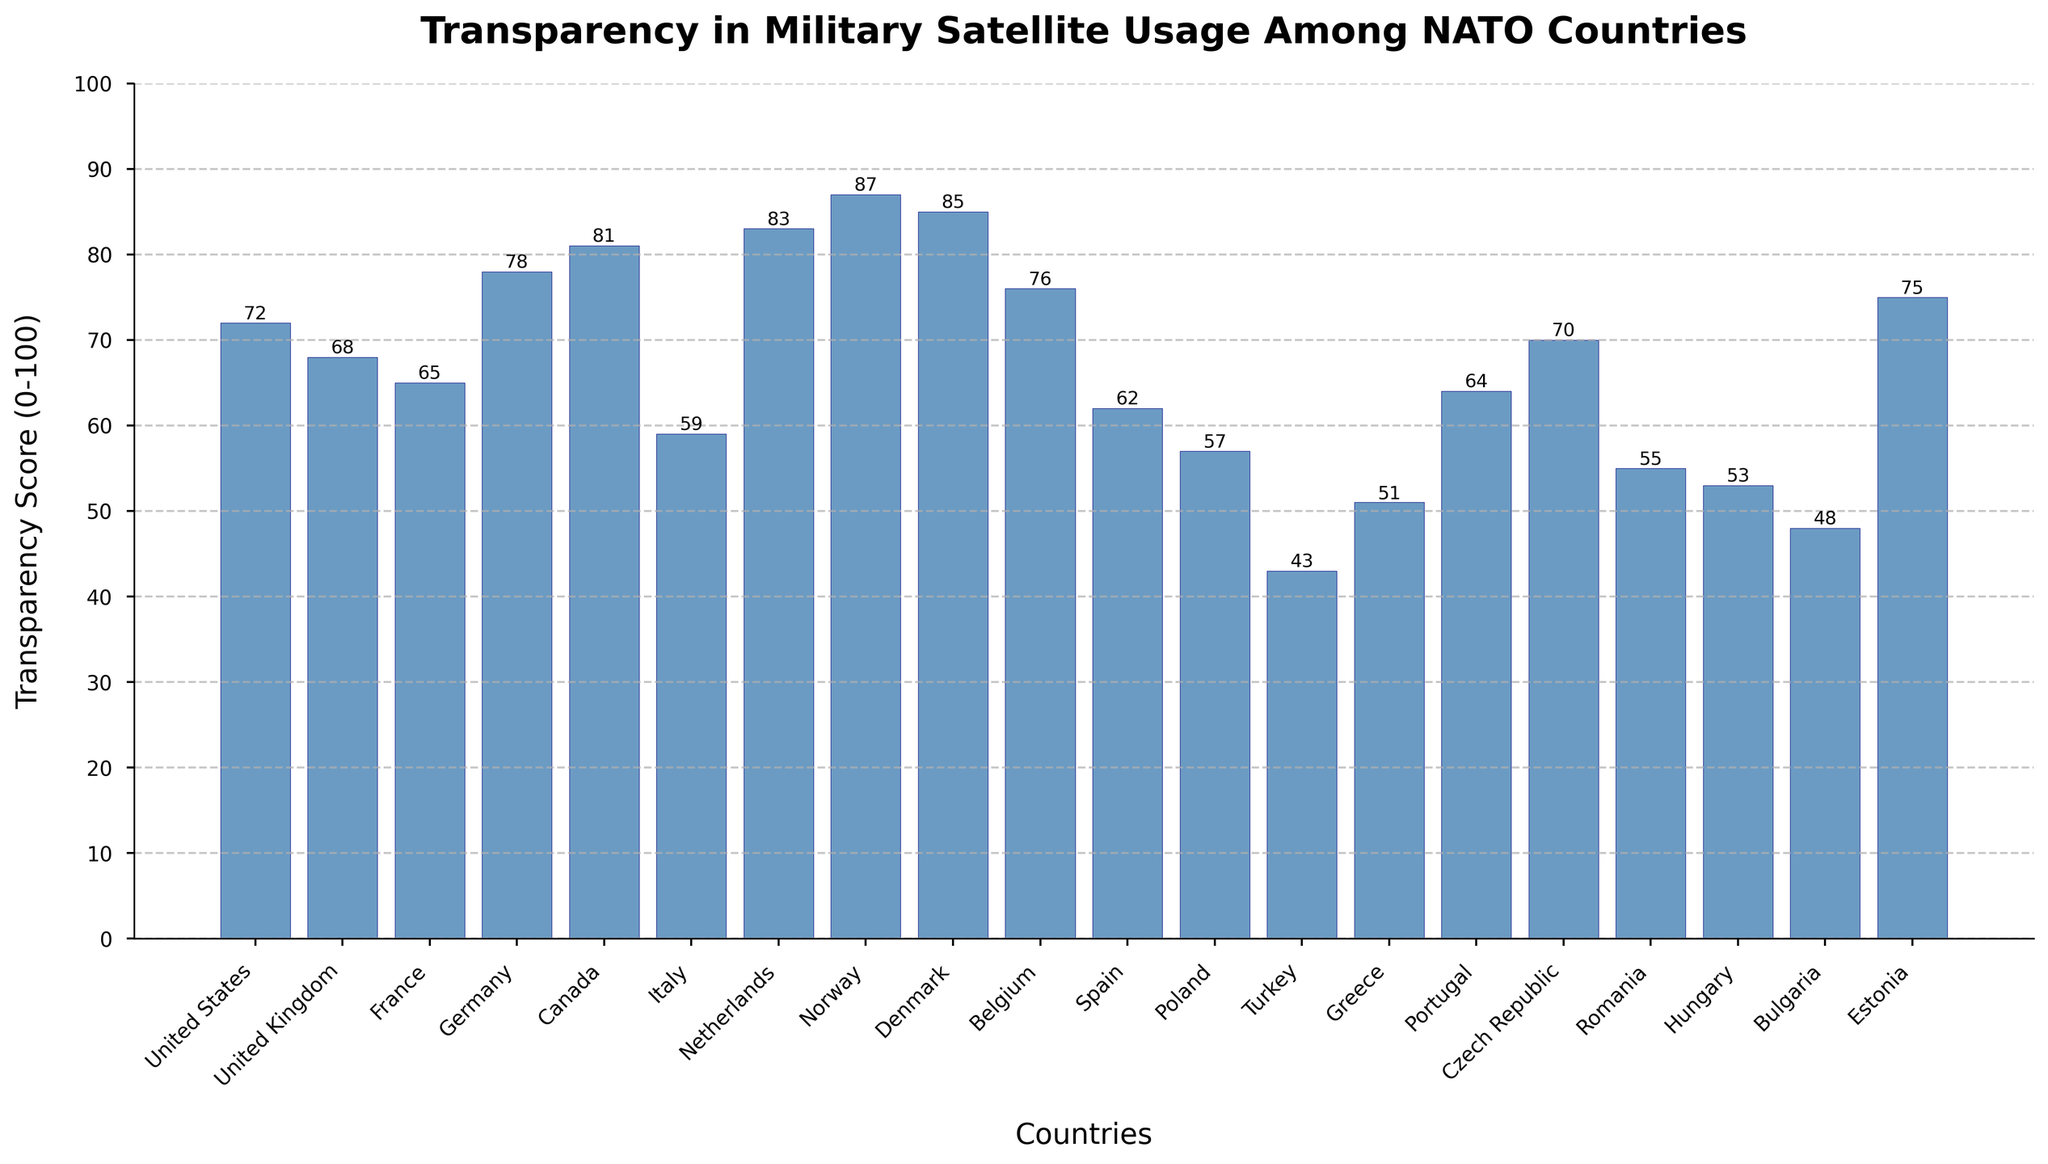Which country has the highest transparency score? By looking at the height of the bars, Norway has the highest transparency score of 87.
Answer: Norway Which country has the lowest transparency score? By observing the smallest bar, Turkey has the lowest transparency score of 43.
Answer: Turkey What is the average transparency score among the NATO countries? Sum all the transparency scores and divide by the number of countries. (72 + 68 + 65 + 78 + 81 + 59 + 83 + 87 + 85 + 76 + 62 + 57 + 43 + 51 + 64 + 70 + 55 + 53 + 48 + 75) / 20 = 68.15
Answer: 68.15 How many countries have a transparency score above 80? Count the bars that exceed the 80 mark. Canada (81), Netherlands (83), Norway (87), and Denmark (85) are above 80.
Answer: 4 Which countries have a transparency score between 70 and 80? Identify the bars that fall between the 70 and 80 range. United States (72), Germany (78), Belgium (76), Czech Republic (70), and Estonia (75) meet the criteria.
Answer: United States, Germany, Belgium, Czech Republic, Estonia What is the difference in transparency score between the highest and the lowest countries? Subtract the score of Turkey (lowest) from Norway (highest). 87 - 43 = 44
Answer: 44 Which country has the closest transparency score to the average score of 68.15? Find the country whose score is closest to 68.15. United Kingdom has a score of 68, which is closest.
Answer: United Kingdom What is the total transparency score of the top 5 countries? Sum the scores of the top 5 countries. Norway (87), Denmark (85), Netherlands (83), Canada (81), Germany (78). 87 + 85 + 83 + 81 + 78 = 414
Answer: 414 Are there more countries with transparency scores above or below 60? Count the number of bars above and below 60. Above 60: 14 countries; Below 60: 6 countries.
Answer: Above What's the median transparency score of the countries? Arrange the scores in order and find the middle value. When sorted: 43, 48, 51, 53, 55, 57, 59, 62, 64, 65, 68, 70, 72, 75, 76, 78, 81, 83, 85, 87. The median is the average of the 10th and 11th values: (65 + 68) / 2 = 66.5
Answer: 66.5 